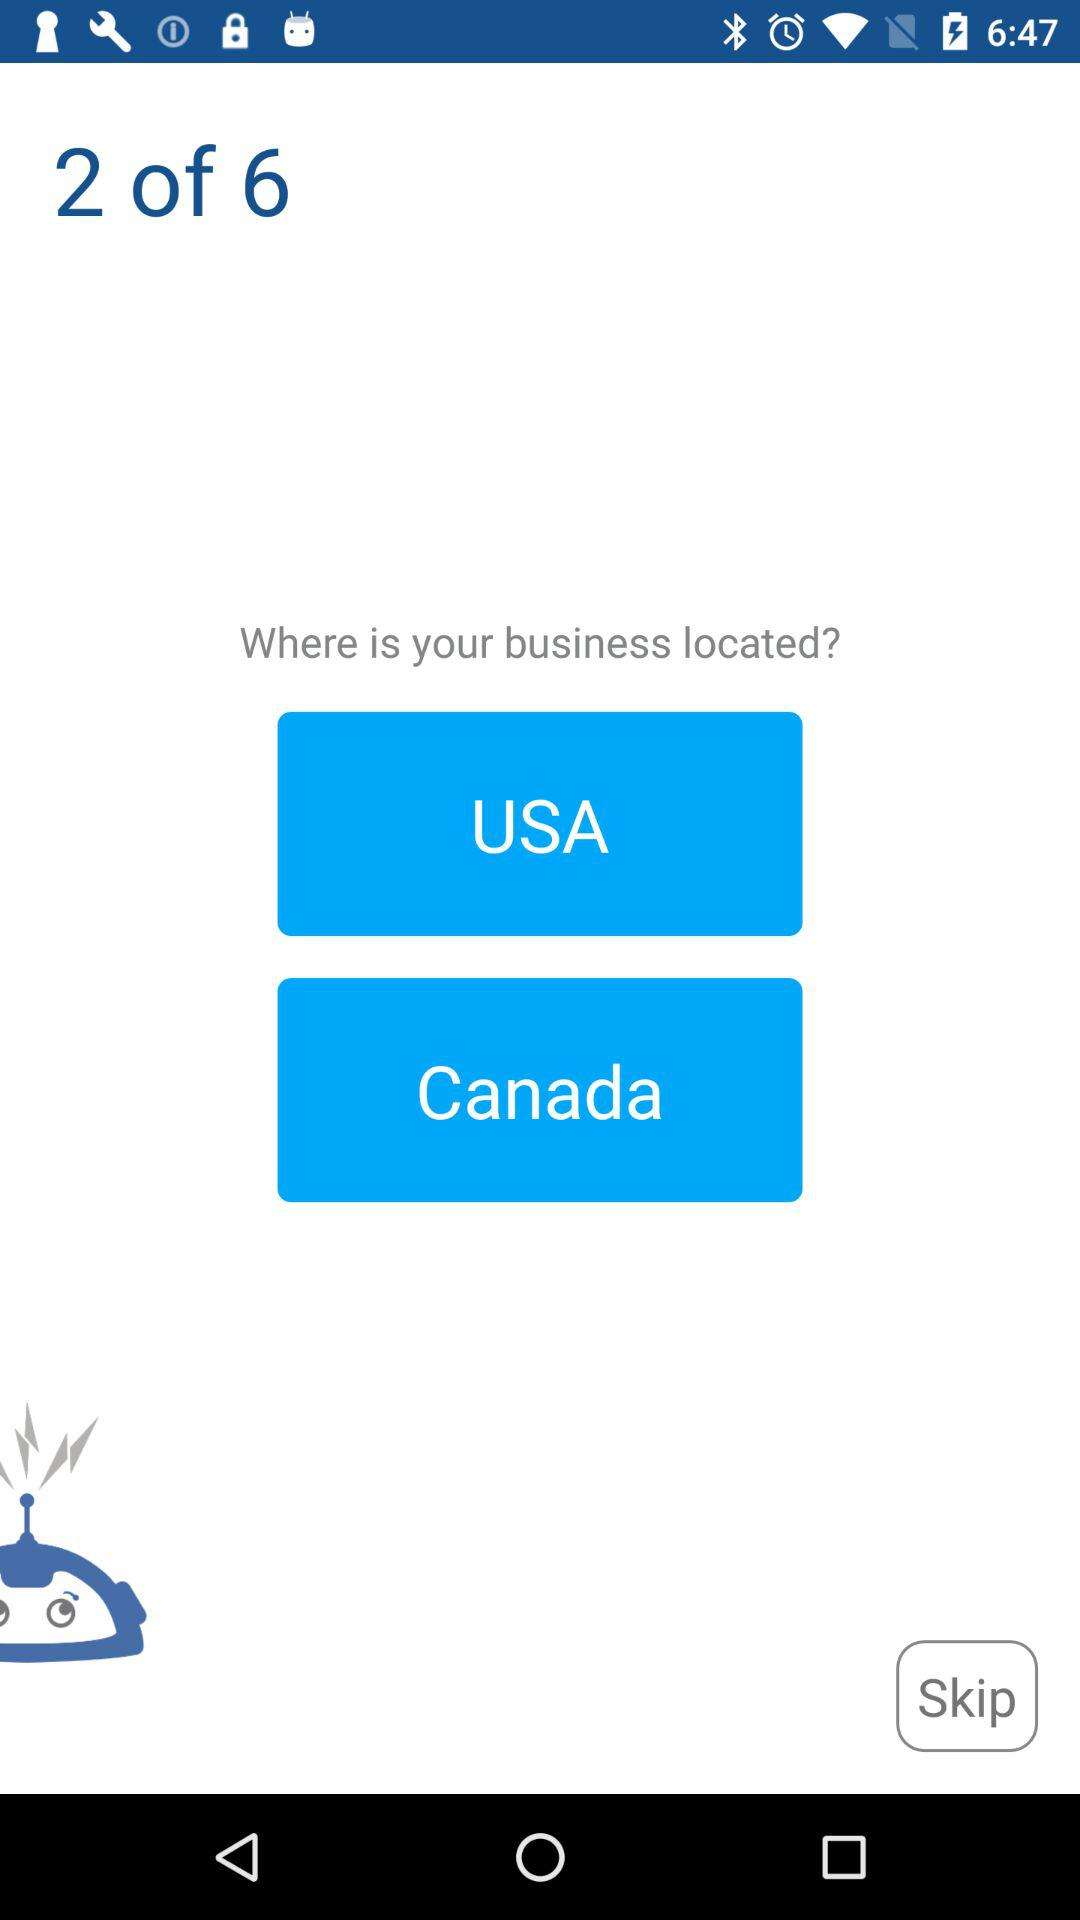Which question am I on now? You are now on the second question. 